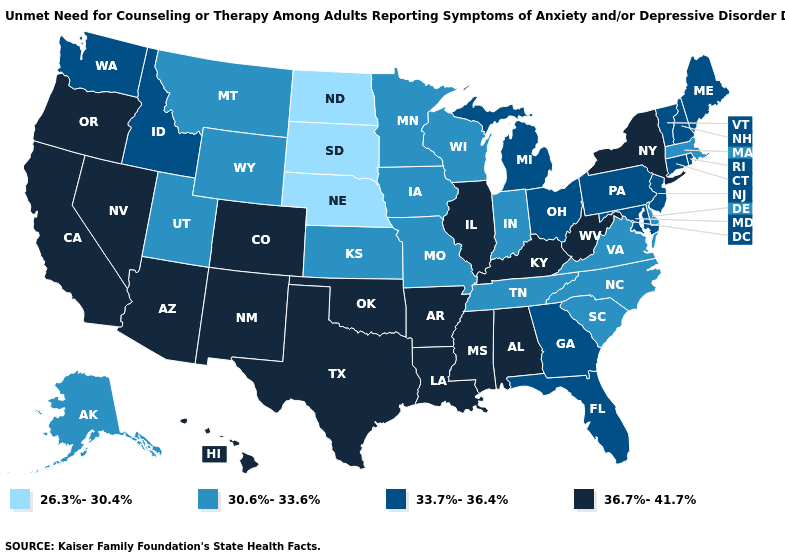Name the states that have a value in the range 30.6%-33.6%?
Keep it brief. Alaska, Delaware, Indiana, Iowa, Kansas, Massachusetts, Minnesota, Missouri, Montana, North Carolina, South Carolina, Tennessee, Utah, Virginia, Wisconsin, Wyoming. Does New York have a higher value than Iowa?
Concise answer only. Yes. Does Indiana have a lower value than Massachusetts?
Give a very brief answer. No. Name the states that have a value in the range 36.7%-41.7%?
Quick response, please. Alabama, Arizona, Arkansas, California, Colorado, Hawaii, Illinois, Kentucky, Louisiana, Mississippi, Nevada, New Mexico, New York, Oklahoma, Oregon, Texas, West Virginia. What is the value of Illinois?
Answer briefly. 36.7%-41.7%. What is the highest value in states that border Oklahoma?
Short answer required. 36.7%-41.7%. Name the states that have a value in the range 36.7%-41.7%?
Give a very brief answer. Alabama, Arizona, Arkansas, California, Colorado, Hawaii, Illinois, Kentucky, Louisiana, Mississippi, Nevada, New Mexico, New York, Oklahoma, Oregon, Texas, West Virginia. Which states have the lowest value in the West?
Concise answer only. Alaska, Montana, Utah, Wyoming. What is the highest value in states that border Maine?
Concise answer only. 33.7%-36.4%. What is the highest value in states that border Maryland?
Answer briefly. 36.7%-41.7%. Which states hav the highest value in the West?
Concise answer only. Arizona, California, Colorado, Hawaii, Nevada, New Mexico, Oregon. Name the states that have a value in the range 26.3%-30.4%?
Write a very short answer. Nebraska, North Dakota, South Dakota. Does Connecticut have the same value as Vermont?
Quick response, please. Yes. Is the legend a continuous bar?
Quick response, please. No. Name the states that have a value in the range 36.7%-41.7%?
Answer briefly. Alabama, Arizona, Arkansas, California, Colorado, Hawaii, Illinois, Kentucky, Louisiana, Mississippi, Nevada, New Mexico, New York, Oklahoma, Oregon, Texas, West Virginia. 